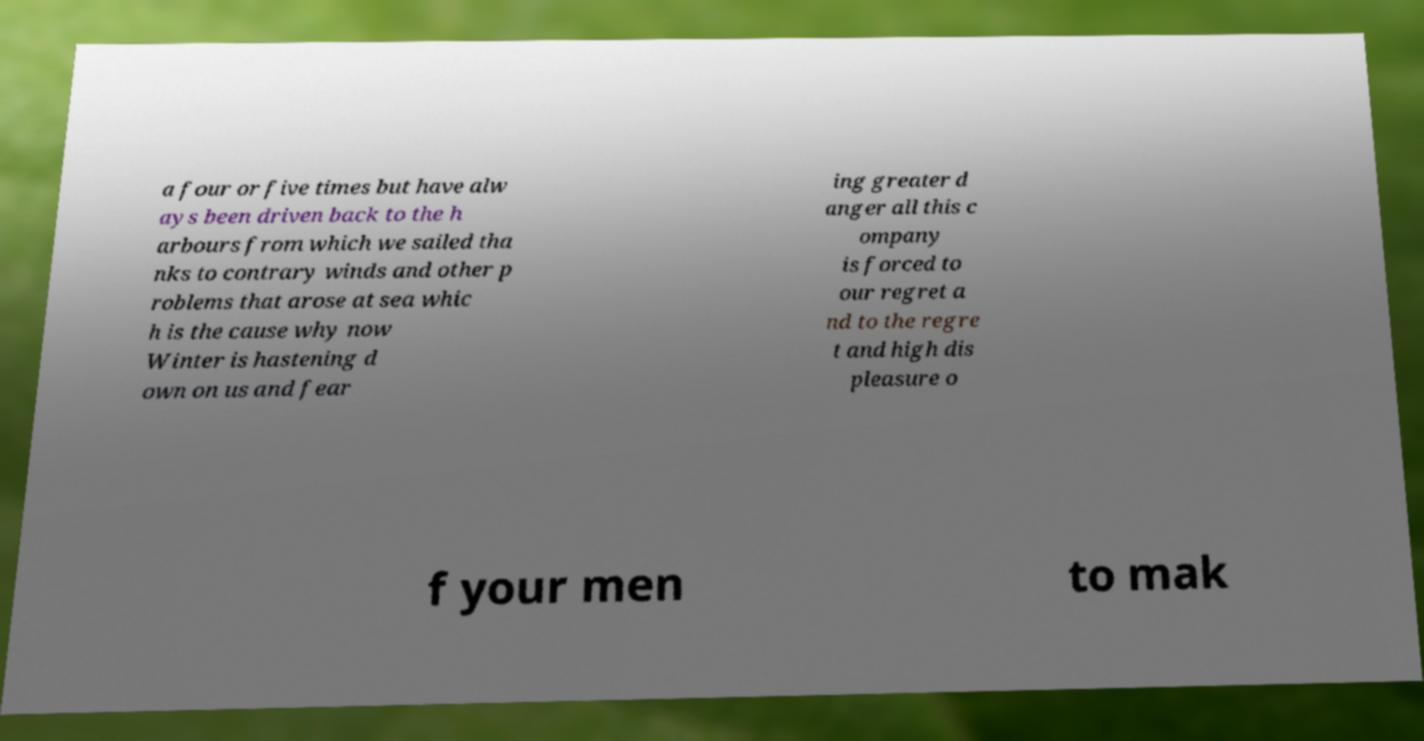What messages or text are displayed in this image? I need them in a readable, typed format. a four or five times but have alw ays been driven back to the h arbours from which we sailed tha nks to contrary winds and other p roblems that arose at sea whic h is the cause why now Winter is hastening d own on us and fear ing greater d anger all this c ompany is forced to our regret a nd to the regre t and high dis pleasure o f your men to mak 